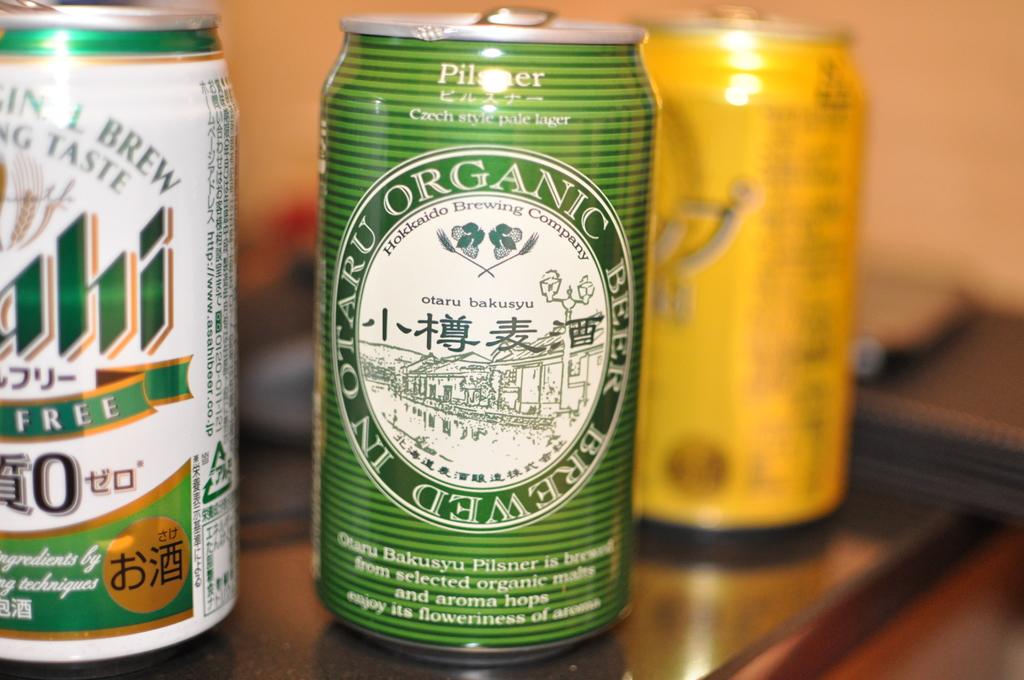What type of beer is in the can?
Provide a succinct answer. Pilsner. Is the beer organic?
Make the answer very short. Yes. 